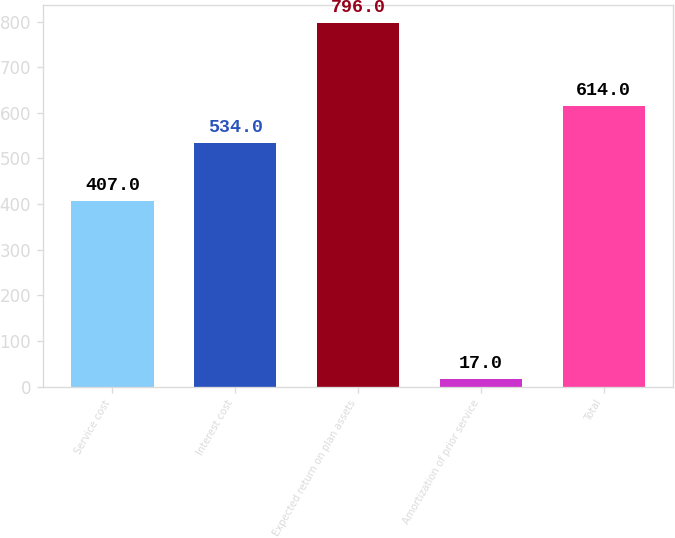Convert chart to OTSL. <chart><loc_0><loc_0><loc_500><loc_500><bar_chart><fcel>Service cost<fcel>Interest cost<fcel>Expected return on plan assets<fcel>Amortization of prior service<fcel>Total<nl><fcel>407<fcel>534<fcel>796<fcel>17<fcel>614<nl></chart> 